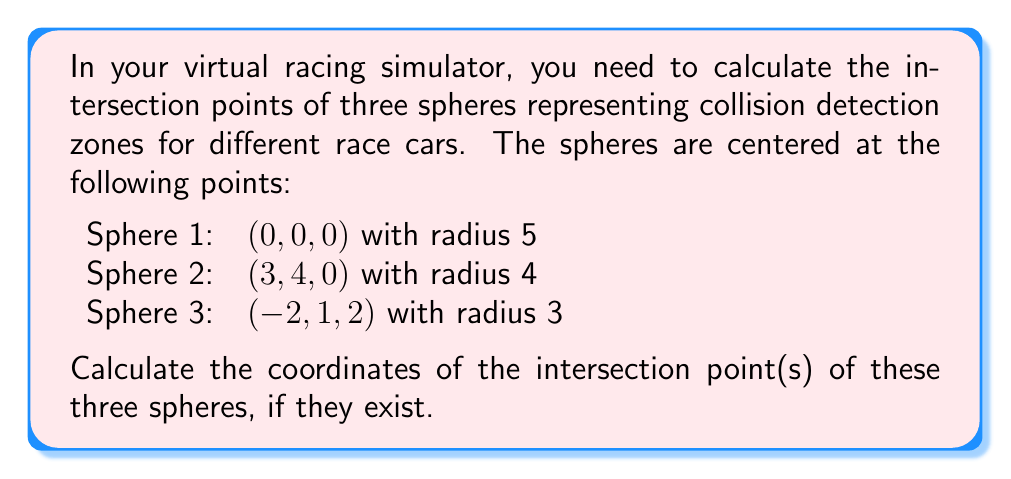Help me with this question. To find the intersection points of three spheres, we need to solve the system of equations representing each sphere:

1) For Sphere 1: $x^2 + y^2 + z^2 = 25$
2) For Sphere 2: $(x-3)^2 + (y-4)^2 + z^2 = 16$
3) For Sphere 3: $(x+2)^2 + (y-1)^2 + (z-2)^2 = 9$

Step 1: Subtract equation 2 from equation 1 to eliminate $x^2 + y^2 + z^2$:
$25 - ((x-3)^2 + (y-4)^2 + z^2) = 25 - 16$
$-x^2 + 6x - 9 - y^2 + 8y - 16 = 9$
$6x + 8y = x^2 + y^2 + 34$

Step 2: Subtract equation 3 from equation 1:
$25 - ((x+2)^2 + (y-1)^2 + (z-2)^2) = 25 - 9$
$-x^2 - 4x - 4 - y^2 + 2y - z^2 + 4z - 4 = 16$
$-4x + 2y + 4z = x^2 + y^2 + z^2 + 24$

Step 3: From steps 1 and 2, we have two equations:
$6x + 8y = x^2 + y^2 + 34$
$-4x + 2y + 4z = x^2 + y^2 + z^2 + 24$

Step 4: Subtract these equations to eliminate $x^2 + y^2$:
$10x + 6y - 4z = 10$

Step 5: Use this equation to express z in terms of x and y:
$z = \frac{10x + 6y - 10}{4}$

Step 6: Substitute this expression for z into equation 3:
$(x+2)^2 + (y-1)^2 + (\frac{10x + 6y - 10}{4} - 2)^2 = 9$

Step 7: Expand and simplify this equation. Then, use it along with the equation from Step 1 to solve for x and y numerically (as the resulting system is non-linear).

Step 8: Using numerical methods or a computer algebra system, we find the solution:
$x \approx 1.5385$
$y \approx 2.1538$
$z \approx 1.4615$

Step 9: Verify that this point satisfies all three original sphere equations.
Answer: $(1.5385, 2.1538, 1.4615)$ 